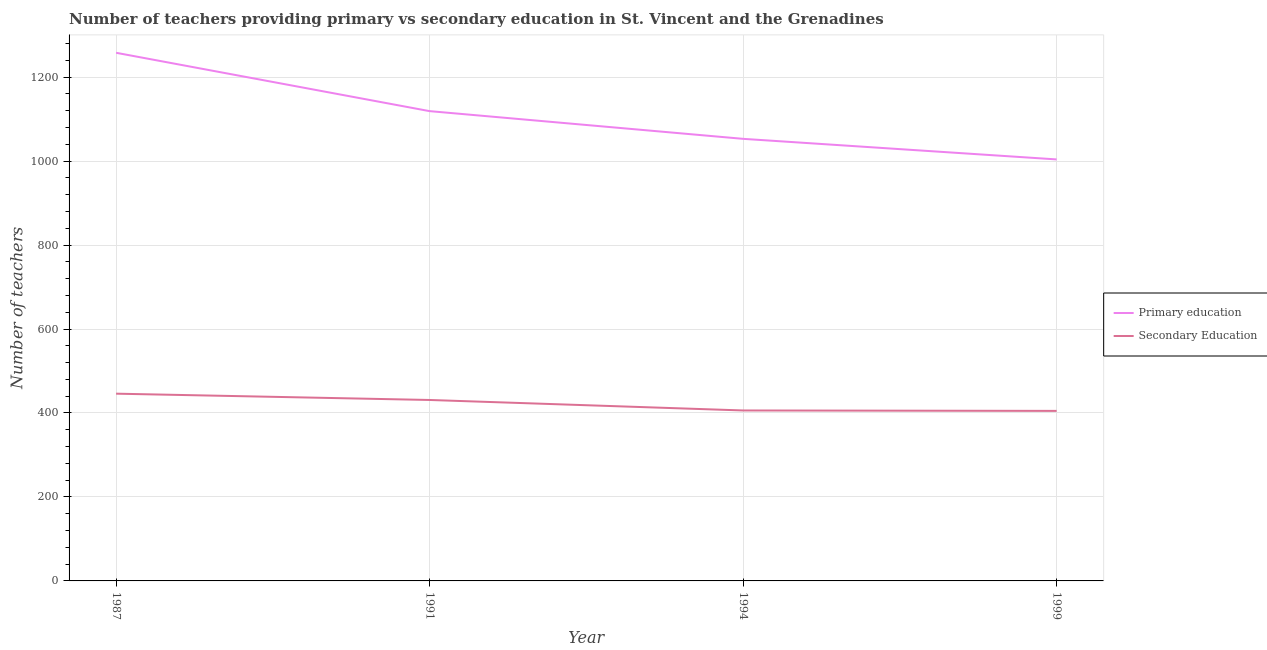Is the number of lines equal to the number of legend labels?
Give a very brief answer. Yes. What is the number of primary teachers in 1987?
Give a very brief answer. 1258. Across all years, what is the maximum number of secondary teachers?
Offer a terse response. 446. Across all years, what is the minimum number of primary teachers?
Offer a very short reply. 1004. What is the total number of secondary teachers in the graph?
Make the answer very short. 1688. What is the difference between the number of primary teachers in 1994 and that in 1999?
Offer a terse response. 49. What is the difference between the number of primary teachers in 1991 and the number of secondary teachers in 1999?
Provide a short and direct response. 714. What is the average number of primary teachers per year?
Your answer should be very brief. 1108.5. In the year 1999, what is the difference between the number of secondary teachers and number of primary teachers?
Your response must be concise. -599. What is the ratio of the number of primary teachers in 1987 to that in 1991?
Keep it short and to the point. 1.12. Is the number of secondary teachers in 1991 less than that in 1994?
Ensure brevity in your answer.  No. What is the difference between the highest and the second highest number of primary teachers?
Offer a terse response. 139. What is the difference between the highest and the lowest number of primary teachers?
Make the answer very short. 254. In how many years, is the number of secondary teachers greater than the average number of secondary teachers taken over all years?
Your answer should be very brief. 2. Is the number of secondary teachers strictly less than the number of primary teachers over the years?
Your response must be concise. Yes. How many lines are there?
Offer a very short reply. 2. What is the difference between two consecutive major ticks on the Y-axis?
Your answer should be compact. 200. Are the values on the major ticks of Y-axis written in scientific E-notation?
Ensure brevity in your answer.  No. Does the graph contain any zero values?
Give a very brief answer. No. How are the legend labels stacked?
Give a very brief answer. Vertical. What is the title of the graph?
Give a very brief answer. Number of teachers providing primary vs secondary education in St. Vincent and the Grenadines. What is the label or title of the X-axis?
Make the answer very short. Year. What is the label or title of the Y-axis?
Your answer should be compact. Number of teachers. What is the Number of teachers of Primary education in 1987?
Offer a very short reply. 1258. What is the Number of teachers in Secondary Education in 1987?
Provide a succinct answer. 446. What is the Number of teachers of Primary education in 1991?
Your response must be concise. 1119. What is the Number of teachers in Secondary Education in 1991?
Give a very brief answer. 431. What is the Number of teachers of Primary education in 1994?
Offer a very short reply. 1053. What is the Number of teachers of Secondary Education in 1994?
Give a very brief answer. 406. What is the Number of teachers of Primary education in 1999?
Provide a succinct answer. 1004. What is the Number of teachers in Secondary Education in 1999?
Make the answer very short. 405. Across all years, what is the maximum Number of teachers of Primary education?
Offer a terse response. 1258. Across all years, what is the maximum Number of teachers in Secondary Education?
Offer a very short reply. 446. Across all years, what is the minimum Number of teachers of Primary education?
Ensure brevity in your answer.  1004. Across all years, what is the minimum Number of teachers of Secondary Education?
Your answer should be very brief. 405. What is the total Number of teachers in Primary education in the graph?
Provide a short and direct response. 4434. What is the total Number of teachers in Secondary Education in the graph?
Make the answer very short. 1688. What is the difference between the Number of teachers in Primary education in 1987 and that in 1991?
Offer a very short reply. 139. What is the difference between the Number of teachers in Secondary Education in 1987 and that in 1991?
Keep it short and to the point. 15. What is the difference between the Number of teachers of Primary education in 1987 and that in 1994?
Your answer should be very brief. 205. What is the difference between the Number of teachers in Secondary Education in 1987 and that in 1994?
Ensure brevity in your answer.  40. What is the difference between the Number of teachers in Primary education in 1987 and that in 1999?
Keep it short and to the point. 254. What is the difference between the Number of teachers of Primary education in 1991 and that in 1994?
Offer a terse response. 66. What is the difference between the Number of teachers in Secondary Education in 1991 and that in 1994?
Offer a terse response. 25. What is the difference between the Number of teachers in Primary education in 1991 and that in 1999?
Offer a terse response. 115. What is the difference between the Number of teachers of Secondary Education in 1991 and that in 1999?
Your answer should be very brief. 26. What is the difference between the Number of teachers of Primary education in 1994 and that in 1999?
Ensure brevity in your answer.  49. What is the difference between the Number of teachers of Primary education in 1987 and the Number of teachers of Secondary Education in 1991?
Provide a short and direct response. 827. What is the difference between the Number of teachers of Primary education in 1987 and the Number of teachers of Secondary Education in 1994?
Make the answer very short. 852. What is the difference between the Number of teachers in Primary education in 1987 and the Number of teachers in Secondary Education in 1999?
Make the answer very short. 853. What is the difference between the Number of teachers in Primary education in 1991 and the Number of teachers in Secondary Education in 1994?
Provide a short and direct response. 713. What is the difference between the Number of teachers of Primary education in 1991 and the Number of teachers of Secondary Education in 1999?
Your response must be concise. 714. What is the difference between the Number of teachers of Primary education in 1994 and the Number of teachers of Secondary Education in 1999?
Ensure brevity in your answer.  648. What is the average Number of teachers of Primary education per year?
Provide a succinct answer. 1108.5. What is the average Number of teachers in Secondary Education per year?
Offer a terse response. 422. In the year 1987, what is the difference between the Number of teachers in Primary education and Number of teachers in Secondary Education?
Offer a very short reply. 812. In the year 1991, what is the difference between the Number of teachers in Primary education and Number of teachers in Secondary Education?
Make the answer very short. 688. In the year 1994, what is the difference between the Number of teachers in Primary education and Number of teachers in Secondary Education?
Give a very brief answer. 647. In the year 1999, what is the difference between the Number of teachers of Primary education and Number of teachers of Secondary Education?
Your answer should be compact. 599. What is the ratio of the Number of teachers in Primary education in 1987 to that in 1991?
Offer a very short reply. 1.12. What is the ratio of the Number of teachers in Secondary Education in 1987 to that in 1991?
Provide a short and direct response. 1.03. What is the ratio of the Number of teachers of Primary education in 1987 to that in 1994?
Your answer should be compact. 1.19. What is the ratio of the Number of teachers in Secondary Education in 1987 to that in 1994?
Offer a terse response. 1.1. What is the ratio of the Number of teachers in Primary education in 1987 to that in 1999?
Offer a terse response. 1.25. What is the ratio of the Number of teachers of Secondary Education in 1987 to that in 1999?
Ensure brevity in your answer.  1.1. What is the ratio of the Number of teachers in Primary education in 1991 to that in 1994?
Keep it short and to the point. 1.06. What is the ratio of the Number of teachers in Secondary Education in 1991 to that in 1994?
Offer a terse response. 1.06. What is the ratio of the Number of teachers in Primary education in 1991 to that in 1999?
Ensure brevity in your answer.  1.11. What is the ratio of the Number of teachers in Secondary Education in 1991 to that in 1999?
Offer a very short reply. 1.06. What is the ratio of the Number of teachers of Primary education in 1994 to that in 1999?
Offer a terse response. 1.05. What is the difference between the highest and the second highest Number of teachers of Primary education?
Provide a succinct answer. 139. What is the difference between the highest and the lowest Number of teachers of Primary education?
Offer a very short reply. 254. What is the difference between the highest and the lowest Number of teachers in Secondary Education?
Provide a short and direct response. 41. 